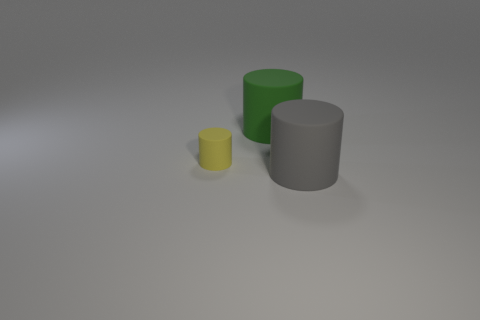What could these cylinders represent if this was a piece of abstract art? If this were an abstract art piece, the cylinders could symbolize different pillars of a concept, with their varying sizes and colors representing different strengths or intensities of certain attributes or emotions. The gray could signify neutrality or balance, while the colored cylinders add dynamic contrast. 